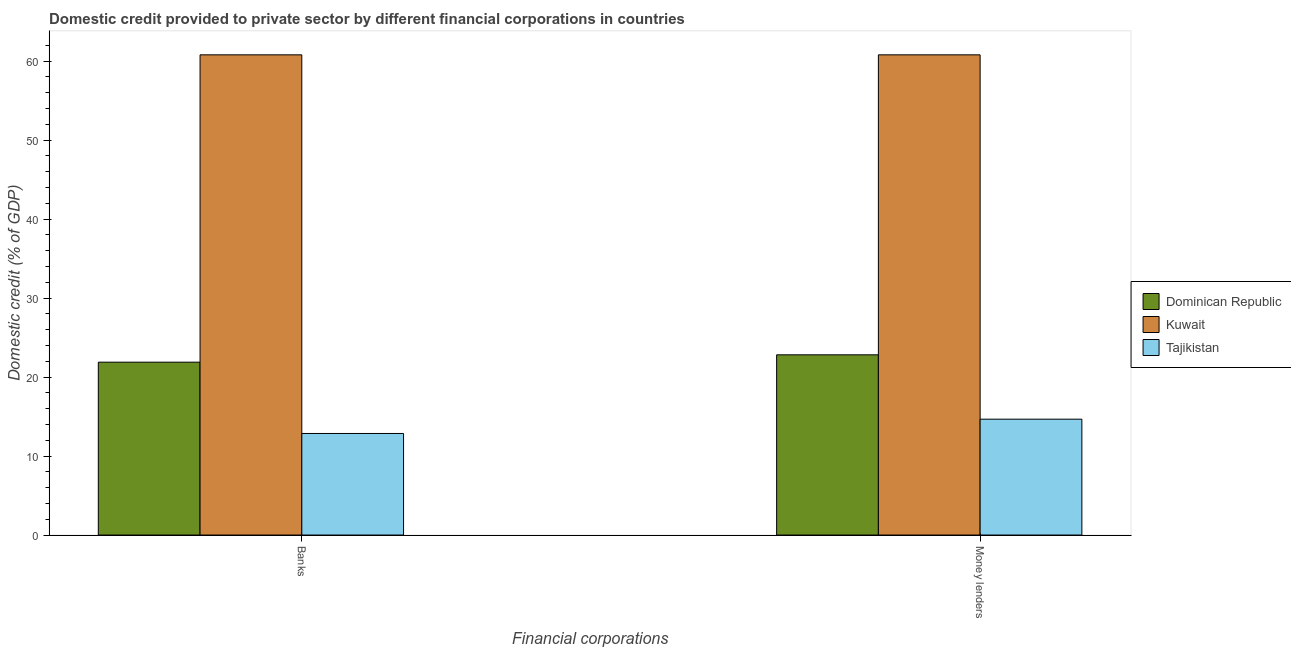How many different coloured bars are there?
Your answer should be very brief. 3. How many groups of bars are there?
Provide a short and direct response. 2. Are the number of bars per tick equal to the number of legend labels?
Ensure brevity in your answer.  Yes. How many bars are there on the 1st tick from the left?
Ensure brevity in your answer.  3. How many bars are there on the 1st tick from the right?
Offer a very short reply. 3. What is the label of the 1st group of bars from the left?
Offer a terse response. Banks. What is the domestic credit provided by money lenders in Kuwait?
Keep it short and to the point. 60.81. Across all countries, what is the maximum domestic credit provided by banks?
Your answer should be very brief. 60.81. Across all countries, what is the minimum domestic credit provided by banks?
Make the answer very short. 12.86. In which country was the domestic credit provided by banks maximum?
Your answer should be very brief. Kuwait. In which country was the domestic credit provided by money lenders minimum?
Ensure brevity in your answer.  Tajikistan. What is the total domestic credit provided by banks in the graph?
Your response must be concise. 95.55. What is the difference between the domestic credit provided by banks in Tajikistan and that in Dominican Republic?
Give a very brief answer. -9.03. What is the difference between the domestic credit provided by money lenders in Tajikistan and the domestic credit provided by banks in Dominican Republic?
Your answer should be very brief. -7.22. What is the average domestic credit provided by banks per country?
Provide a short and direct response. 31.85. In how many countries, is the domestic credit provided by banks greater than 36 %?
Your answer should be compact. 1. What is the ratio of the domestic credit provided by banks in Kuwait to that in Tajikistan?
Your answer should be compact. 4.73. What does the 1st bar from the left in Banks represents?
Your answer should be very brief. Dominican Republic. What does the 3rd bar from the right in Banks represents?
Keep it short and to the point. Dominican Republic. Are all the bars in the graph horizontal?
Keep it short and to the point. No. How many countries are there in the graph?
Offer a very short reply. 3. Does the graph contain grids?
Make the answer very short. No. How many legend labels are there?
Give a very brief answer. 3. How are the legend labels stacked?
Provide a succinct answer. Vertical. What is the title of the graph?
Keep it short and to the point. Domestic credit provided to private sector by different financial corporations in countries. Does "Low & middle income" appear as one of the legend labels in the graph?
Your response must be concise. No. What is the label or title of the X-axis?
Your answer should be compact. Financial corporations. What is the label or title of the Y-axis?
Provide a succinct answer. Domestic credit (% of GDP). What is the Domestic credit (% of GDP) in Dominican Republic in Banks?
Your response must be concise. 21.89. What is the Domestic credit (% of GDP) in Kuwait in Banks?
Provide a succinct answer. 60.81. What is the Domestic credit (% of GDP) of Tajikistan in Banks?
Your answer should be compact. 12.86. What is the Domestic credit (% of GDP) of Dominican Republic in Money lenders?
Keep it short and to the point. 22.82. What is the Domestic credit (% of GDP) in Kuwait in Money lenders?
Your answer should be compact. 60.81. What is the Domestic credit (% of GDP) of Tajikistan in Money lenders?
Your answer should be compact. 14.67. Across all Financial corporations, what is the maximum Domestic credit (% of GDP) in Dominican Republic?
Provide a succinct answer. 22.82. Across all Financial corporations, what is the maximum Domestic credit (% of GDP) in Kuwait?
Give a very brief answer. 60.81. Across all Financial corporations, what is the maximum Domestic credit (% of GDP) in Tajikistan?
Offer a terse response. 14.67. Across all Financial corporations, what is the minimum Domestic credit (% of GDP) in Dominican Republic?
Offer a very short reply. 21.89. Across all Financial corporations, what is the minimum Domestic credit (% of GDP) in Kuwait?
Make the answer very short. 60.81. Across all Financial corporations, what is the minimum Domestic credit (% of GDP) in Tajikistan?
Make the answer very short. 12.86. What is the total Domestic credit (% of GDP) of Dominican Republic in the graph?
Provide a short and direct response. 44.71. What is the total Domestic credit (% of GDP) in Kuwait in the graph?
Give a very brief answer. 121.61. What is the total Domestic credit (% of GDP) of Tajikistan in the graph?
Offer a terse response. 27.53. What is the difference between the Domestic credit (% of GDP) of Dominican Republic in Banks and that in Money lenders?
Keep it short and to the point. -0.93. What is the difference between the Domestic credit (% of GDP) of Tajikistan in Banks and that in Money lenders?
Provide a short and direct response. -1.81. What is the difference between the Domestic credit (% of GDP) of Dominican Republic in Banks and the Domestic credit (% of GDP) of Kuwait in Money lenders?
Keep it short and to the point. -38.92. What is the difference between the Domestic credit (% of GDP) of Dominican Republic in Banks and the Domestic credit (% of GDP) of Tajikistan in Money lenders?
Your response must be concise. 7.22. What is the difference between the Domestic credit (% of GDP) of Kuwait in Banks and the Domestic credit (% of GDP) of Tajikistan in Money lenders?
Provide a succinct answer. 46.14. What is the average Domestic credit (% of GDP) of Dominican Republic per Financial corporations?
Ensure brevity in your answer.  22.35. What is the average Domestic credit (% of GDP) in Kuwait per Financial corporations?
Provide a succinct answer. 60.81. What is the average Domestic credit (% of GDP) in Tajikistan per Financial corporations?
Provide a short and direct response. 13.77. What is the difference between the Domestic credit (% of GDP) of Dominican Republic and Domestic credit (% of GDP) of Kuwait in Banks?
Provide a short and direct response. -38.92. What is the difference between the Domestic credit (% of GDP) in Dominican Republic and Domestic credit (% of GDP) in Tajikistan in Banks?
Your response must be concise. 9.03. What is the difference between the Domestic credit (% of GDP) of Kuwait and Domestic credit (% of GDP) of Tajikistan in Banks?
Provide a short and direct response. 47.95. What is the difference between the Domestic credit (% of GDP) in Dominican Republic and Domestic credit (% of GDP) in Kuwait in Money lenders?
Provide a succinct answer. -37.99. What is the difference between the Domestic credit (% of GDP) in Dominican Republic and Domestic credit (% of GDP) in Tajikistan in Money lenders?
Your answer should be very brief. 8.15. What is the difference between the Domestic credit (% of GDP) in Kuwait and Domestic credit (% of GDP) in Tajikistan in Money lenders?
Provide a succinct answer. 46.14. What is the ratio of the Domestic credit (% of GDP) in Dominican Republic in Banks to that in Money lenders?
Offer a terse response. 0.96. What is the ratio of the Domestic credit (% of GDP) in Tajikistan in Banks to that in Money lenders?
Your answer should be compact. 0.88. What is the difference between the highest and the second highest Domestic credit (% of GDP) in Dominican Republic?
Give a very brief answer. 0.93. What is the difference between the highest and the second highest Domestic credit (% of GDP) of Tajikistan?
Your answer should be very brief. 1.81. What is the difference between the highest and the lowest Domestic credit (% of GDP) in Dominican Republic?
Keep it short and to the point. 0.93. What is the difference between the highest and the lowest Domestic credit (% of GDP) of Tajikistan?
Provide a short and direct response. 1.81. 